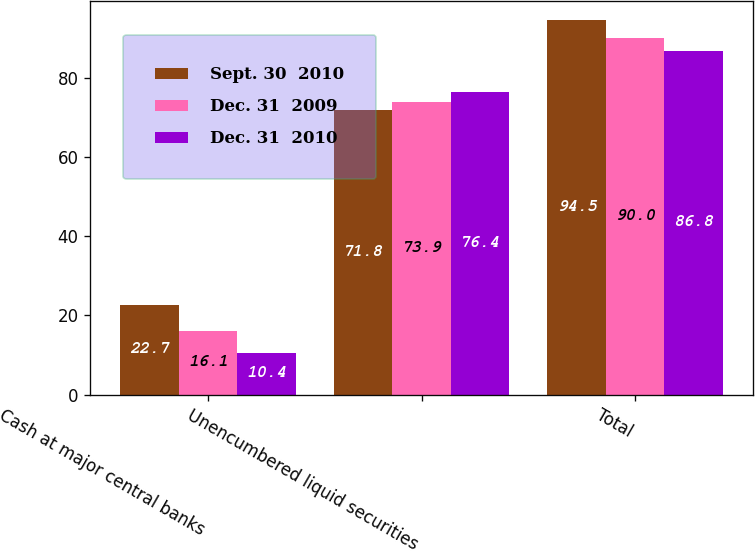<chart> <loc_0><loc_0><loc_500><loc_500><stacked_bar_chart><ecel><fcel>Cash at major central banks<fcel>Unencumbered liquid securities<fcel>Total<nl><fcel>Sept. 30  2010<fcel>22.7<fcel>71.8<fcel>94.5<nl><fcel>Dec. 31  2009<fcel>16.1<fcel>73.9<fcel>90<nl><fcel>Dec. 31  2010<fcel>10.4<fcel>76.4<fcel>86.8<nl></chart> 